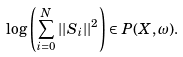Convert formula to latex. <formula><loc_0><loc_0><loc_500><loc_500>\log \left ( \sum _ { i = 0 } ^ { N } | | S _ { i } | | ^ { 2 } \right ) \in P ( X , \omega ) .</formula> 